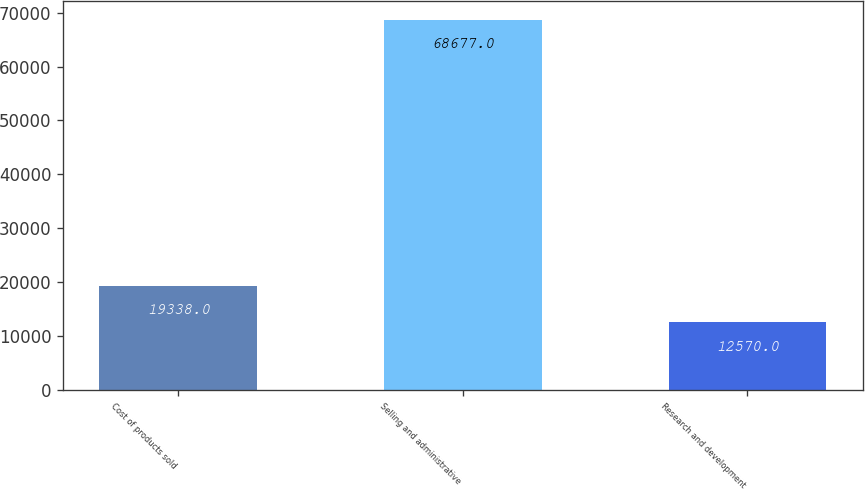<chart> <loc_0><loc_0><loc_500><loc_500><bar_chart><fcel>Cost of products sold<fcel>Selling and administrative<fcel>Research and development<nl><fcel>19338<fcel>68677<fcel>12570<nl></chart> 